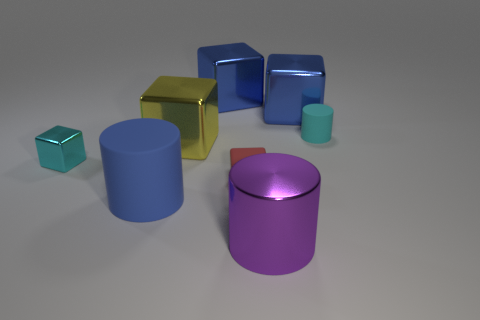Subtract 2 blocks. How many blocks are left? 3 Subtract all red cubes. How many cubes are left? 4 Subtract all large yellow cubes. How many cubes are left? 4 Subtract all brown blocks. Subtract all blue cylinders. How many blocks are left? 5 Add 1 small purple rubber things. How many objects exist? 9 Subtract all cylinders. How many objects are left? 5 Add 2 purple objects. How many purple objects are left? 3 Add 7 purple metal objects. How many purple metal objects exist? 8 Subtract 2 blue blocks. How many objects are left? 6 Subtract all small cyan shiny objects. Subtract all small green metal objects. How many objects are left? 7 